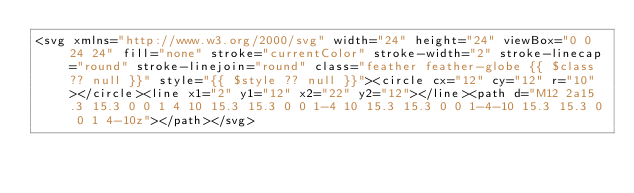<code> <loc_0><loc_0><loc_500><loc_500><_PHP_><svg xmlns="http://www.w3.org/2000/svg" width="24" height="24" viewBox="0 0 24 24" fill="none" stroke="currentColor" stroke-width="2" stroke-linecap="round" stroke-linejoin="round" class="feather feather-globe {{ $class ?? null }}" style="{{ $style ?? null }}"><circle cx="12" cy="12" r="10"></circle><line x1="2" y1="12" x2="22" y2="12"></line><path d="M12 2a15.3 15.3 0 0 1 4 10 15.3 15.3 0 0 1-4 10 15.3 15.3 0 0 1-4-10 15.3 15.3 0 0 1 4-10z"></path></svg></code> 